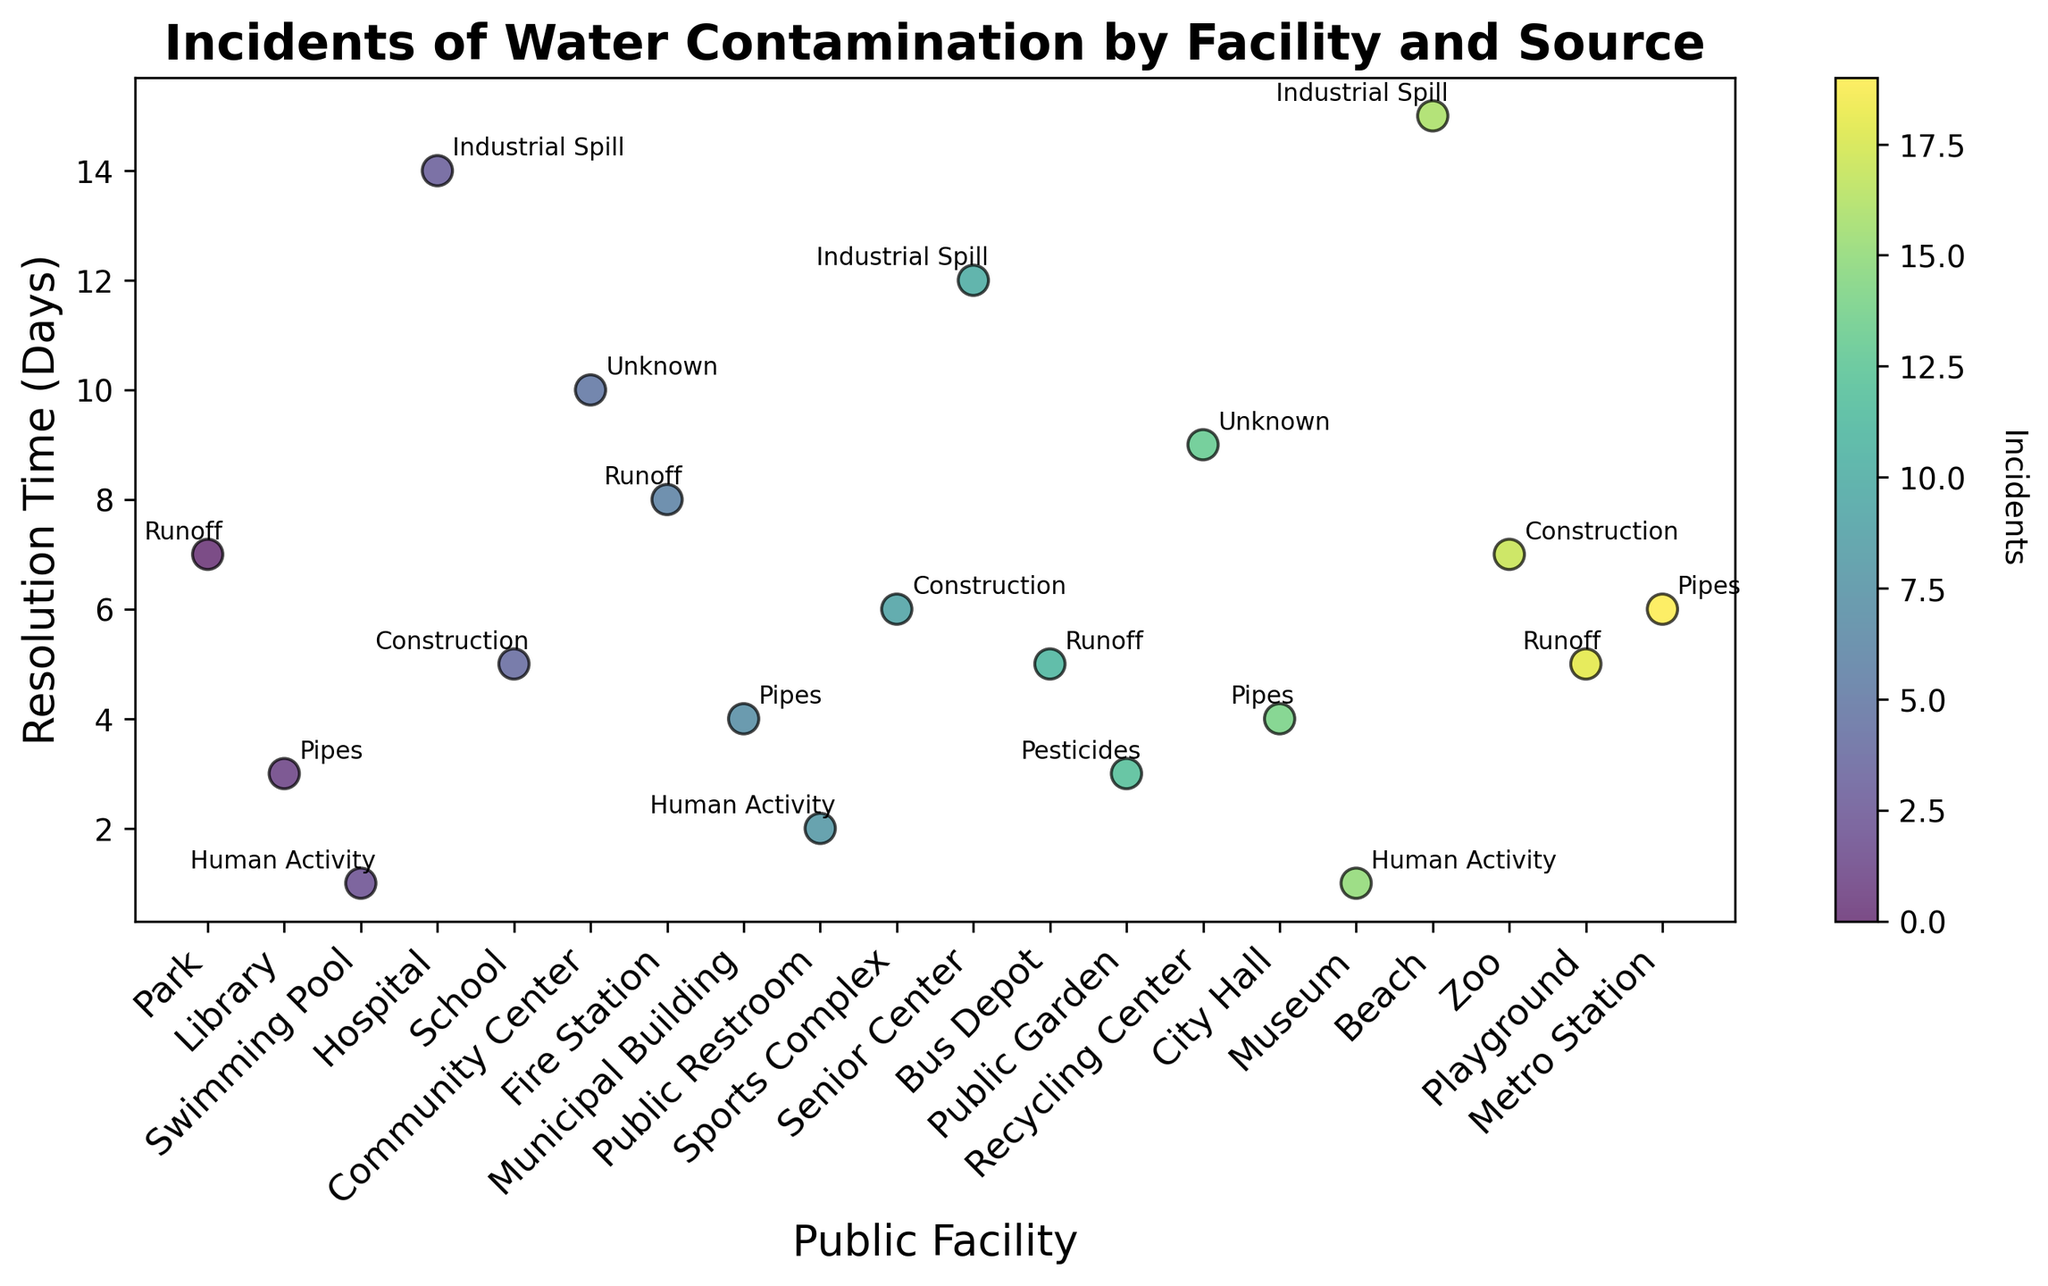Which facility had the longest resolution time for water contamination incidents? To determine this, look for the highest point on the y-axis and observe the facility name it corresponds to.
Answer: Beach What was the resolution time for water contamination incidents at the City Hall? Find the 'City Hall' facility on the x-axis and read its corresponding y-axis value.
Answer: 4 days Which source of contamination had the shortest average resolution time? The annotation near the point with the lowest average resolution time indicates the source. The shortest time corresponds to the source with the minimum value on the y-axis.
Answer: Human Activity Did any contamination incidents related to "Human Activity" get resolved in exactly 1 day? Look for the label "Human Activity" on the annotated points and see if any of these point to the y-axis value of 1.
Answer: Yes Compare the resolution time of incidents at the 'Beach' with those at the 'Hospital.' Which one took longer? Locate both 'Beach' and 'Hospital' on the x-axis and compare their corresponding y-values. The higher value indicates a longer resolution time.
Answer: Beach How many days longer was the resolution time for the Industrial Spill incident at the Beach compared to that at the Hospital? Subtract the y-axis value for 'Hospital' from the y-axis value for 'Beach' when both have the label "Industrial Spill."
Answer: 1 day Was the average resolution time for Industrial Spill incidents longer or shorter than for Construction-related incidents? Find and compare the average resolution times annotated for "Industrial Spill" and "Construction". The positions on the y-axis provide the comparison.
Answer: Longer What's the difference in resolution times for incidents caused by Pipelines at the Municipal Building and the Metro Station? Identify points labeled "Pipes" at both the Municipal Building and Metro Station and compute their difference in y-axis values.
Answer: 2 days What contamination source had an incident resolved in exactly 10 days, and which facility was it? Find the point at y-axis value 10 and confirm its label annotation and x-axis facility name.
Answer: Unknown, Community Center Between the Park and the Playground, which facility had a shorter resolution time for water contamination incidents caused by Runoff? Compare the y-axis values of the points labeled "Runoff" for 'Park' and 'Playground'. The smaller value indicates a shorter resolution time.
Answer: Playground 